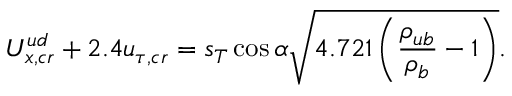<formula> <loc_0><loc_0><loc_500><loc_500>U _ { x , c r } ^ { u d } + 2 . 4 u _ { \tau , c r } = s _ { T } \cos \alpha \sqrt { 4 . 7 2 1 \left ( \frac { \rho _ { u b } } { \rho _ { b } } - 1 \right ) } .</formula> 